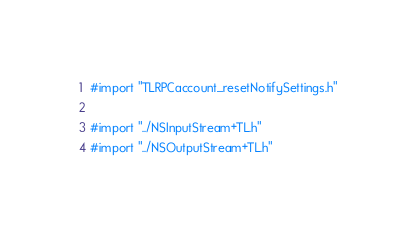Convert code to text. <code><loc_0><loc_0><loc_500><loc_500><_ObjectiveC_>#import "TLRPCaccount_resetNotifySettings.h"

#import "../NSInputStream+TL.h"
#import "../NSOutputStream+TL.h"

</code> 